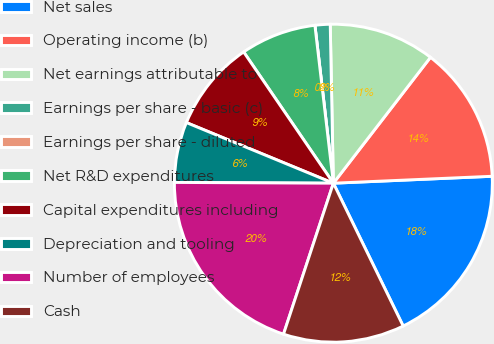Convert chart. <chart><loc_0><loc_0><loc_500><loc_500><pie_chart><fcel>Net sales<fcel>Operating income (b)<fcel>Net earnings attributable to<fcel>Earnings per share - basic (c)<fcel>Earnings per share - diluted<fcel>Net R&D expenditures<fcel>Capital expenditures including<fcel>Depreciation and tooling<fcel>Number of employees<fcel>Cash<nl><fcel>18.46%<fcel>13.85%<fcel>10.77%<fcel>1.54%<fcel>0.0%<fcel>7.69%<fcel>9.23%<fcel>6.15%<fcel>20.0%<fcel>12.31%<nl></chart> 